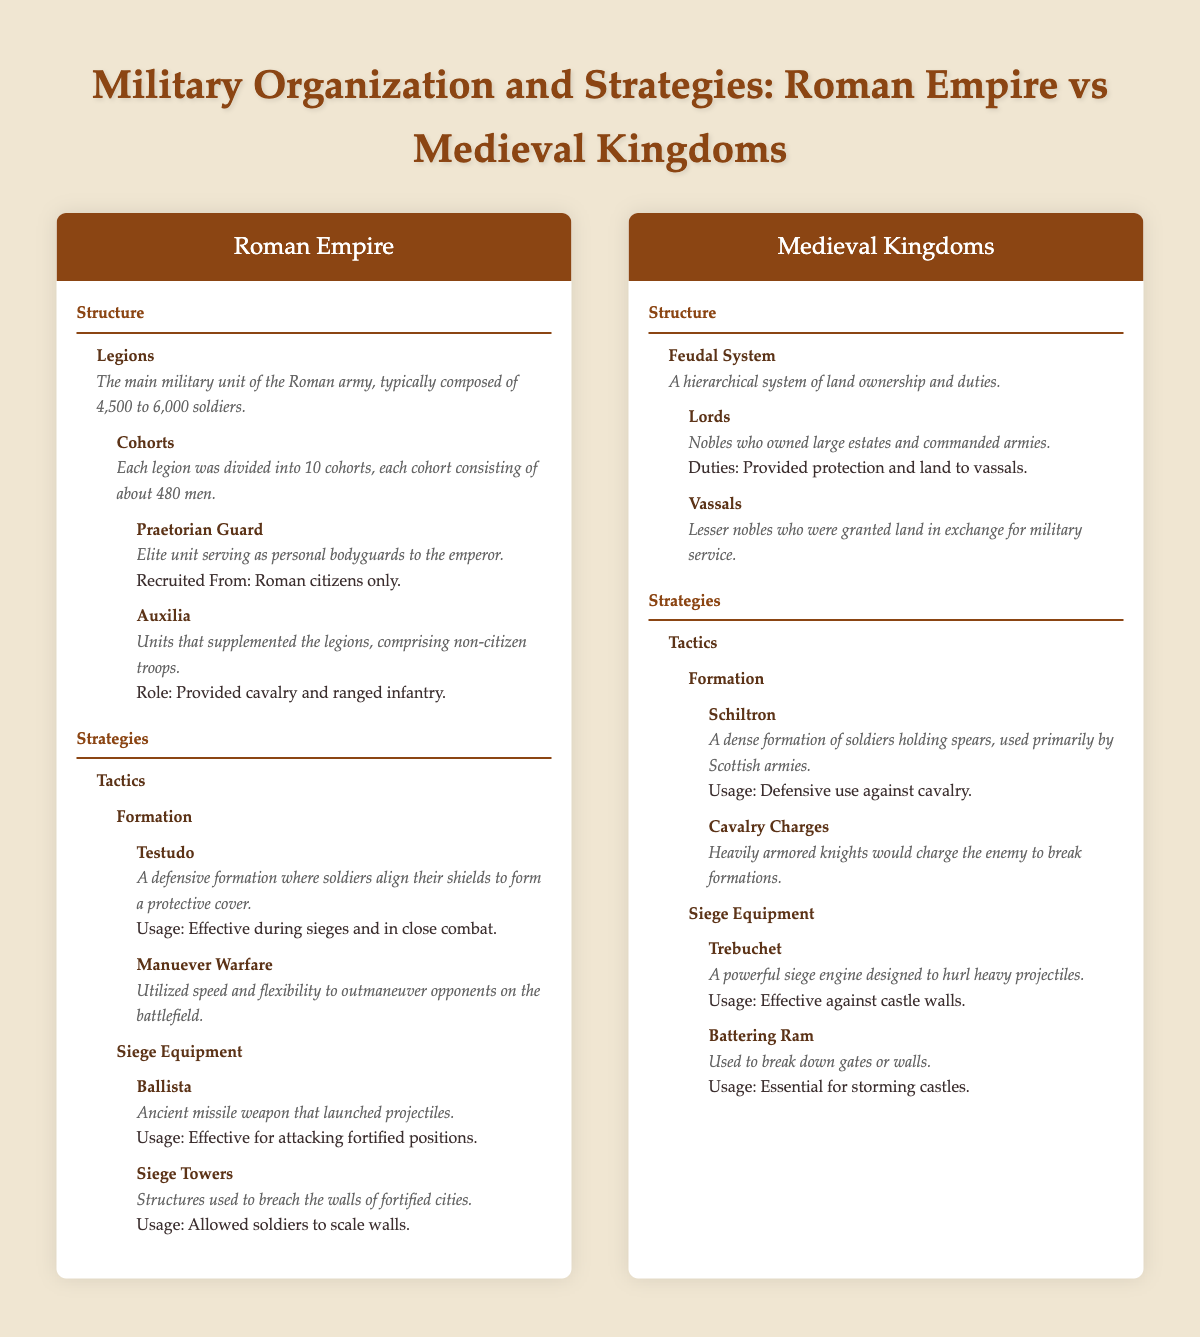What is the main military unit of the Roman Empire? The table states that the main military unit of the Roman Empire is the "Legions," which are composed of 4,500 to 6,000 soldiers.
Answer: Legions How many cohorts are in a Roman legion? It is mentioned that each Roman legion consists of 10 cohorts.
Answer: 10 What role did the Auxilia serve in the Roman Empire? The Auxilia provided supplemental troops to the legions and mainly comprised non-citizen troops, providing cavalry and ranged infantry support.
Answer: Provided cavalry and ranged infantry Did Medieval kingdoms use siege towers? The table indicates that siege towers were a part of Roman strategies but does not mention them in the context of Medieval kingdoms, implying they did not widely use this equipment.
Answer: No Which siege equipment used by Medieval kingdoms is specifically mentioned as effective against castle walls? The table highlights the "Trebuchet" as a powerful siege engine designed to hurl heavy projectiles and states it is effective against castle walls.
Answer: Trebuchet Based on the descriptions, which military formation emphasizes defense against cavalry? The "Schiltron" is described as a dense formation of soldiers holding spears and is used defensively against cavalry.
Answer: Schiltron How do the recruitment practices of the Praetorian Guard differ from those of the Auxilia in the Roman Empire? The Praetorian Guard strictly recruited from Roman citizens only, whereas the Auxilia comprised non-citizen troops, indicating differing recruitment bases.
Answer: Praetorian Guard from citizens; Auxilia from non-citizens Overall, which military organization appears to be more hierarchical, the Roman Empire or Medieval kingdoms? The Roman Empire's structure involves a clear hierarchy within the legions, while the Medieval kingdoms structured their military around the feudal system, indicating more levels of hierarchy.
Answer: Medieval kingdoms What is the total basic composition of a Roman legion considering the definition of both legions and cohorts? A Roman legion is composed of between 4,500 to 6,000 soldiers, and since there are 10 cohorts in a legion, this composition reflects a well-organized military unit leading to its strategic advantages.
Answer: 4,500 to 6,000 soldiers 